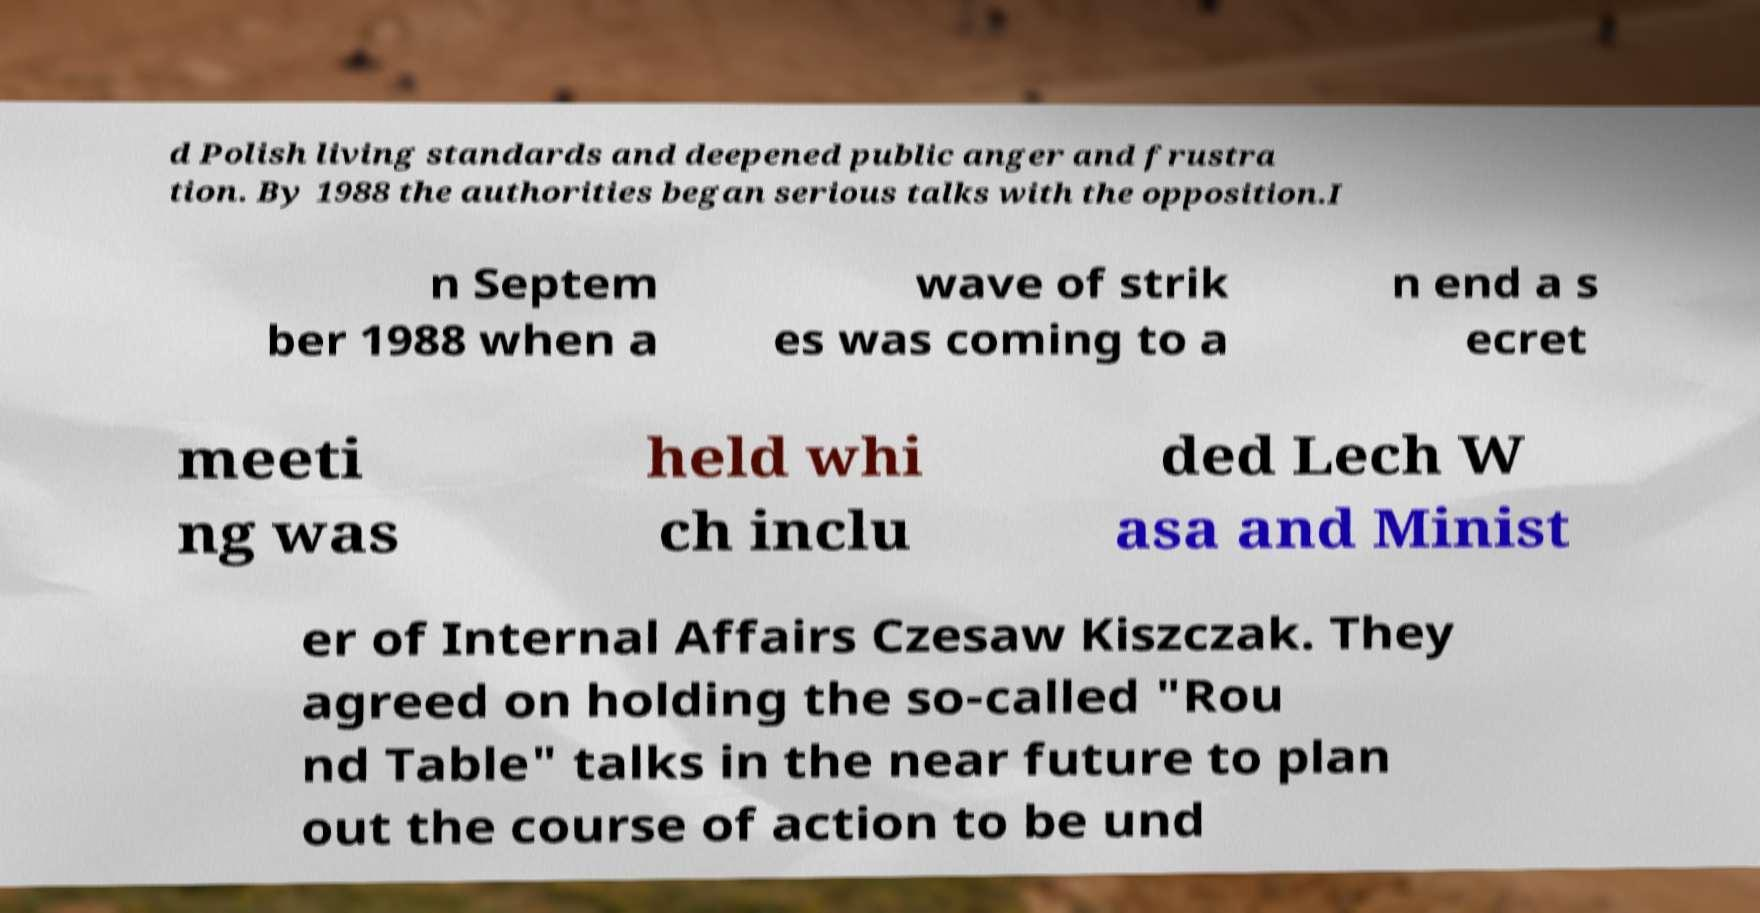Could you extract and type out the text from this image? d Polish living standards and deepened public anger and frustra tion. By 1988 the authorities began serious talks with the opposition.I n Septem ber 1988 when a wave of strik es was coming to a n end a s ecret meeti ng was held whi ch inclu ded Lech W asa and Minist er of Internal Affairs Czesaw Kiszczak. They agreed on holding the so-called "Rou nd Table" talks in the near future to plan out the course of action to be und 